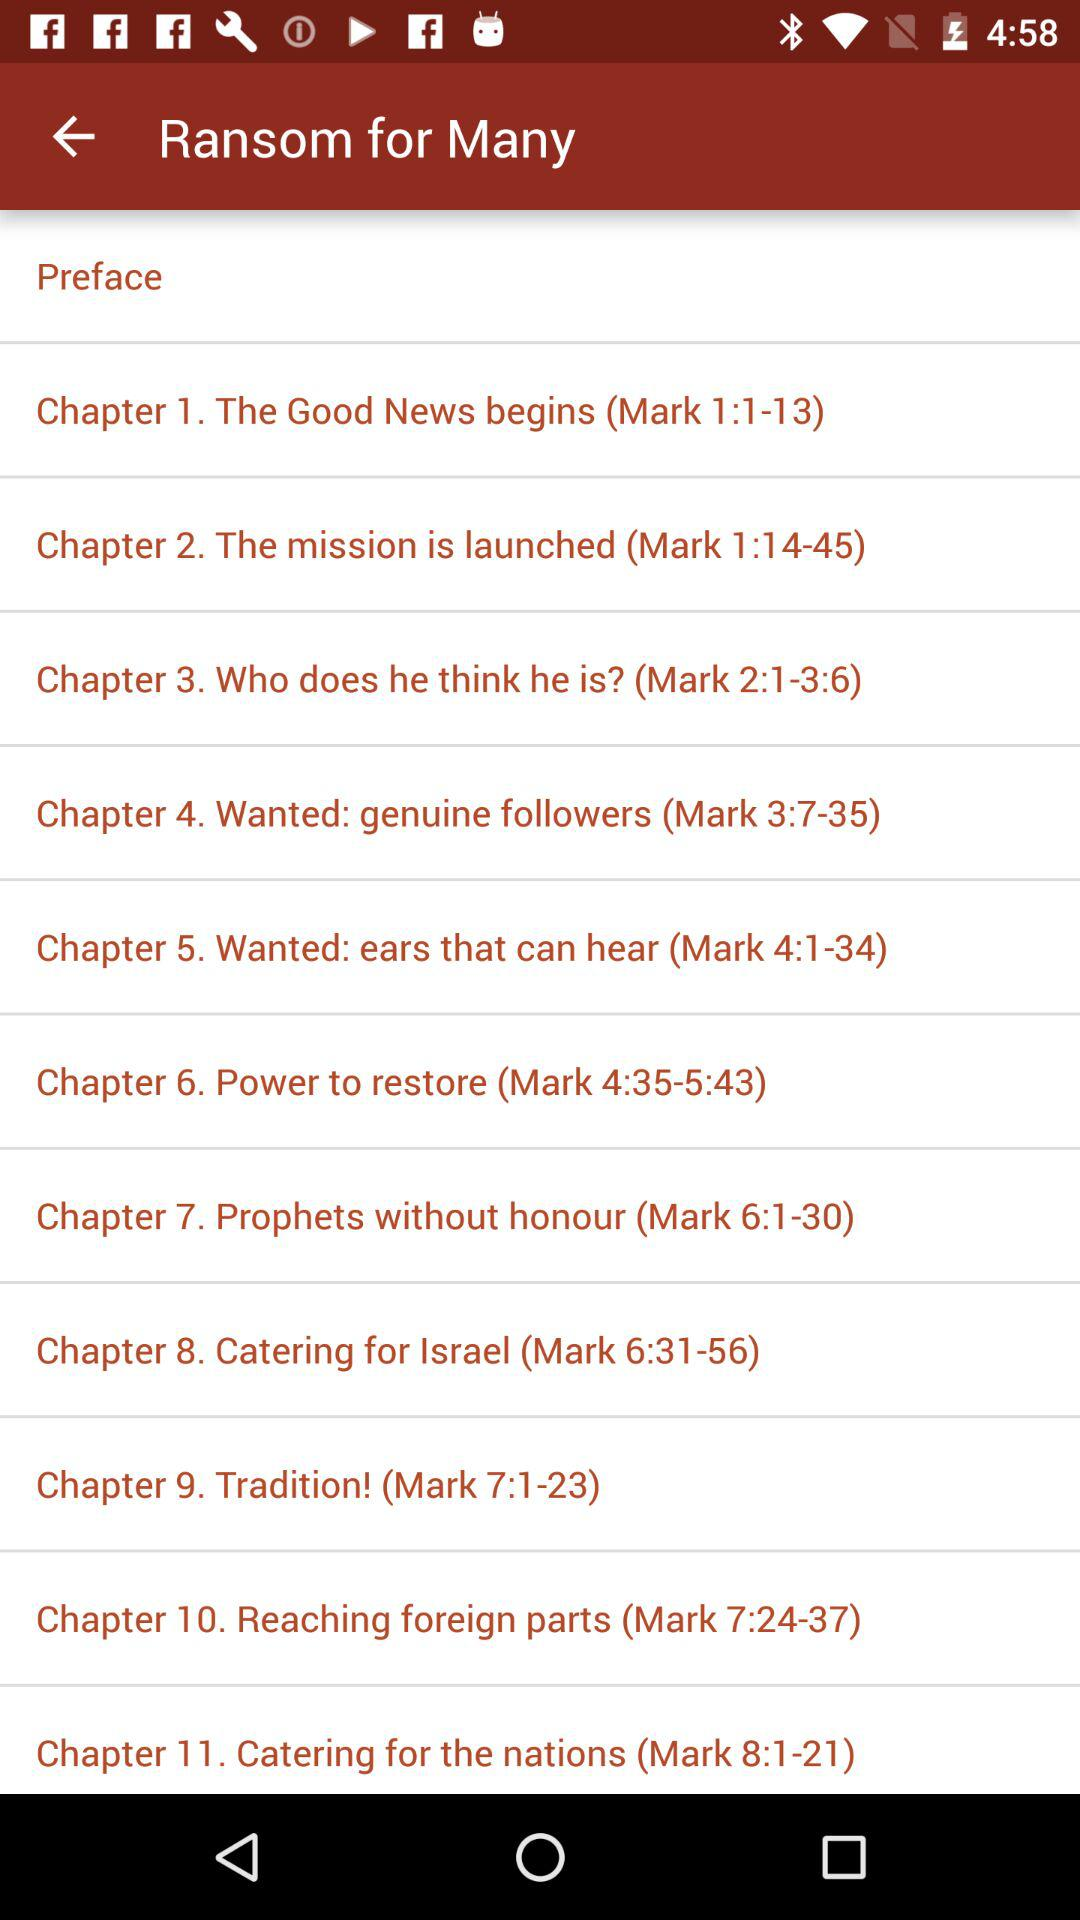How many chapters are there in the book?
Answer the question using a single word or phrase. 11 